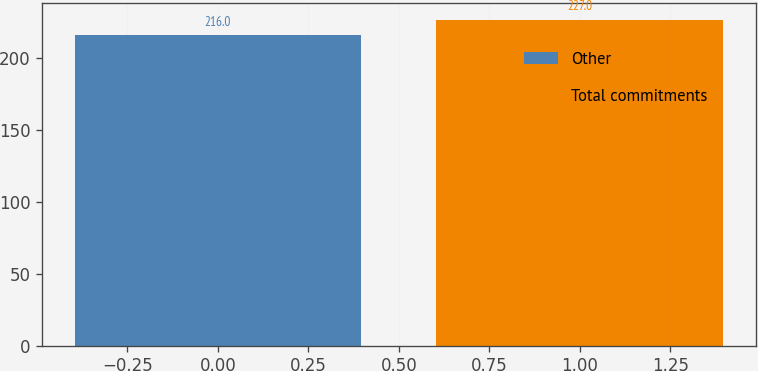<chart> <loc_0><loc_0><loc_500><loc_500><bar_chart><fcel>Other<fcel>Total commitments<nl><fcel>216<fcel>227<nl></chart> 